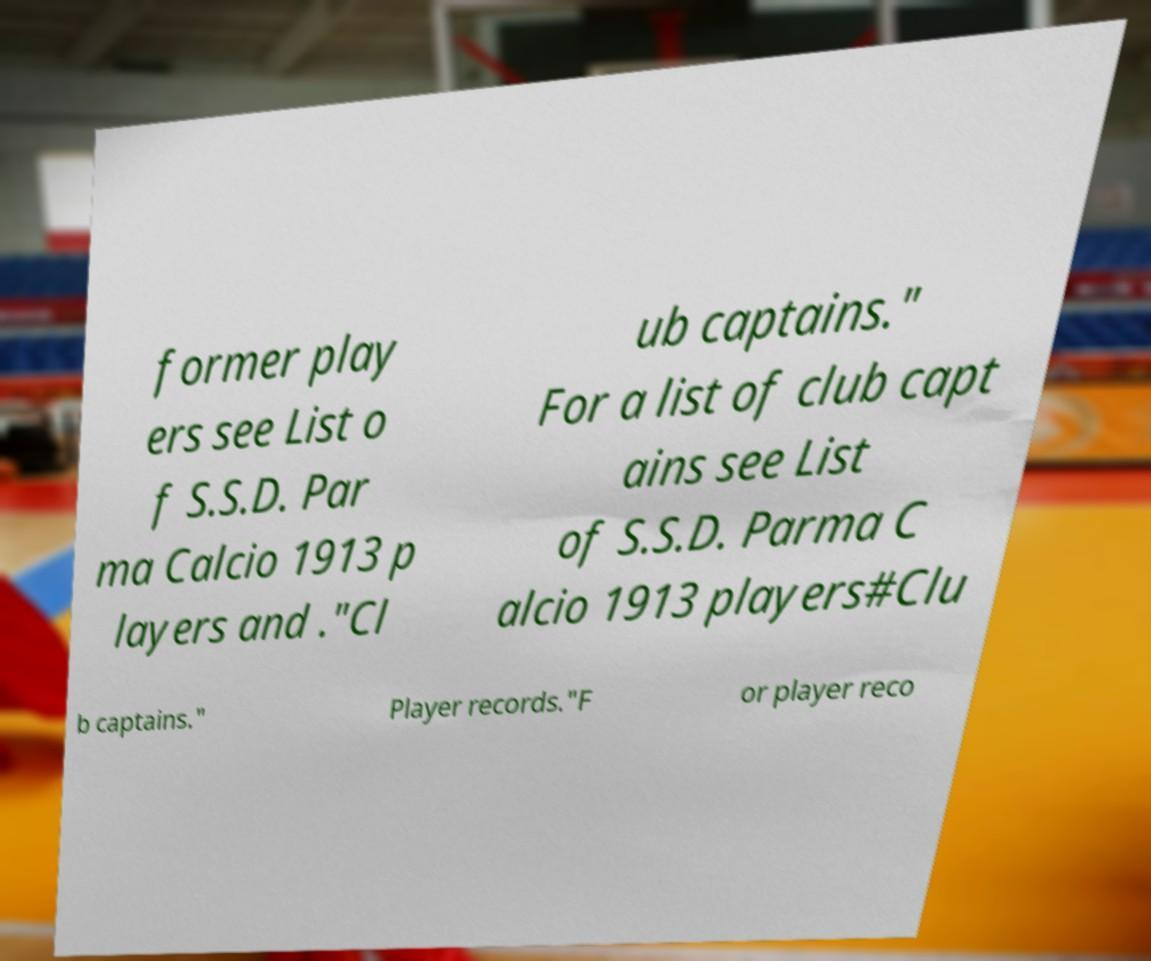Can you read and provide the text displayed in the image?This photo seems to have some interesting text. Can you extract and type it out for me? former play ers see List o f S.S.D. Par ma Calcio 1913 p layers and ."Cl ub captains." For a list of club capt ains see List of S.S.D. Parma C alcio 1913 players#Clu b captains." Player records."F or player reco 